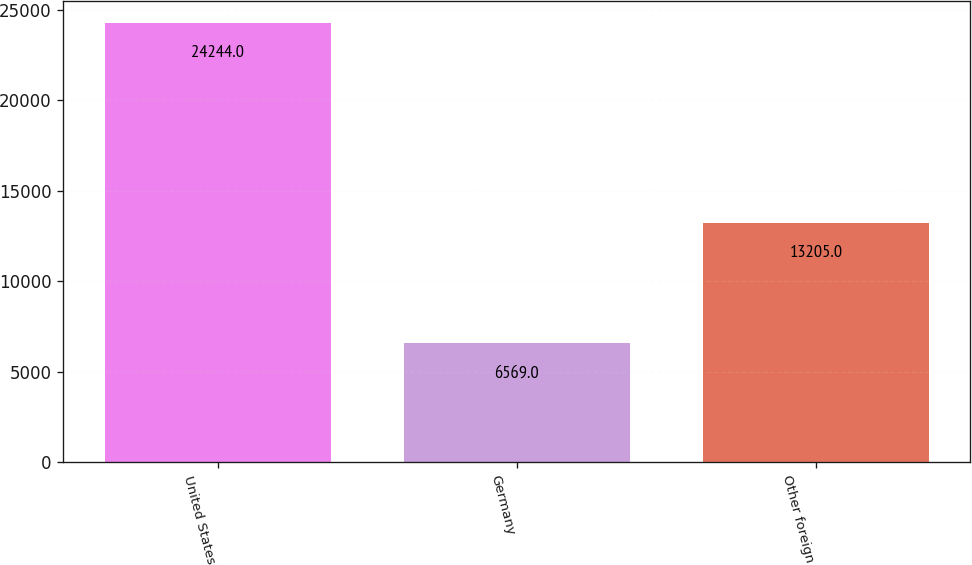Convert chart. <chart><loc_0><loc_0><loc_500><loc_500><bar_chart><fcel>United States<fcel>Germany<fcel>Other foreign<nl><fcel>24244<fcel>6569<fcel>13205<nl></chart> 